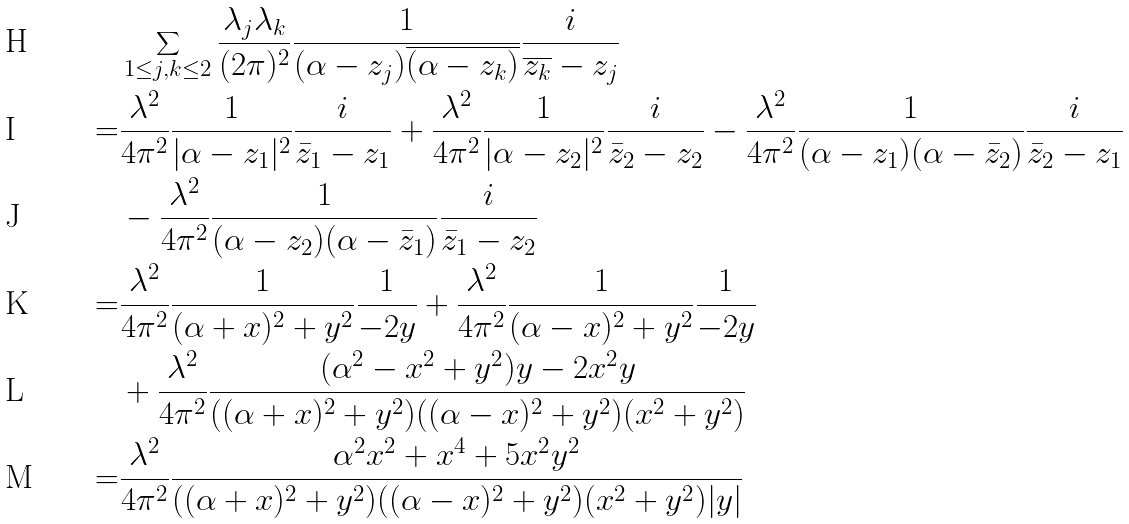<formula> <loc_0><loc_0><loc_500><loc_500>& \sum _ { 1 \leq j , k \leq 2 } \frac { \lambda _ { j } \lambda _ { k } } { ( 2 \pi ) ^ { 2 } } \frac { 1 } { ( \alpha - z _ { j } ) \overline { ( \alpha - z _ { k } ) } } \frac { i } { \overline { z _ { k } } - z _ { j } } \\ = & \frac { \lambda ^ { 2 } } { 4 \pi ^ { 2 } } \frac { 1 } { | \alpha - z _ { 1 } | ^ { 2 } } \frac { i } { \bar { z } _ { 1 } - z _ { 1 } } + \frac { \lambda ^ { 2 } } { 4 \pi ^ { 2 } } \frac { 1 } { | \alpha - z _ { 2 } | ^ { 2 } } \frac { i } { \bar { z } _ { 2 } - z _ { 2 } } - \frac { \lambda ^ { 2 } } { 4 \pi ^ { 2 } } \frac { 1 } { ( \alpha - z _ { 1 } ) ( \alpha - \bar { z } _ { 2 } ) } \frac { i } { \bar { z } _ { 2 } - z _ { 1 } } \\ & - \frac { \lambda ^ { 2 } } { 4 \pi ^ { 2 } } \frac { 1 } { ( \alpha - z _ { 2 } ) ( \alpha - \bar { z } _ { 1 } ) } \frac { i } { \bar { z } _ { 1 } - z _ { 2 } } \\ = & \frac { \lambda ^ { 2 } } { 4 \pi ^ { 2 } } \frac { 1 } { ( \alpha + x ) ^ { 2 } + y ^ { 2 } } \frac { 1 } { - 2 y } + \frac { \lambda ^ { 2 } } { 4 \pi ^ { 2 } } \frac { 1 } { ( \alpha - x ) ^ { 2 } + y ^ { 2 } } \frac { 1 } { - 2 y } \\ & + \frac { \lambda ^ { 2 } } { 4 \pi ^ { 2 } } \frac { ( \alpha ^ { 2 } - x ^ { 2 } + y ^ { 2 } ) y - 2 x ^ { 2 } y } { ( ( \alpha + x ) ^ { 2 } + y ^ { 2 } ) ( ( \alpha - x ) ^ { 2 } + y ^ { 2 } ) ( x ^ { 2 } + y ^ { 2 } ) } \\ = & \frac { \lambda ^ { 2 } } { 4 \pi ^ { 2 } } \frac { \alpha ^ { 2 } x ^ { 2 } + x ^ { 4 } + 5 x ^ { 2 } y ^ { 2 } } { ( ( \alpha + x ) ^ { 2 } + y ^ { 2 } ) ( ( \alpha - x ) ^ { 2 } + y ^ { 2 } ) ( x ^ { 2 } + y ^ { 2 } ) | y | }</formula> 